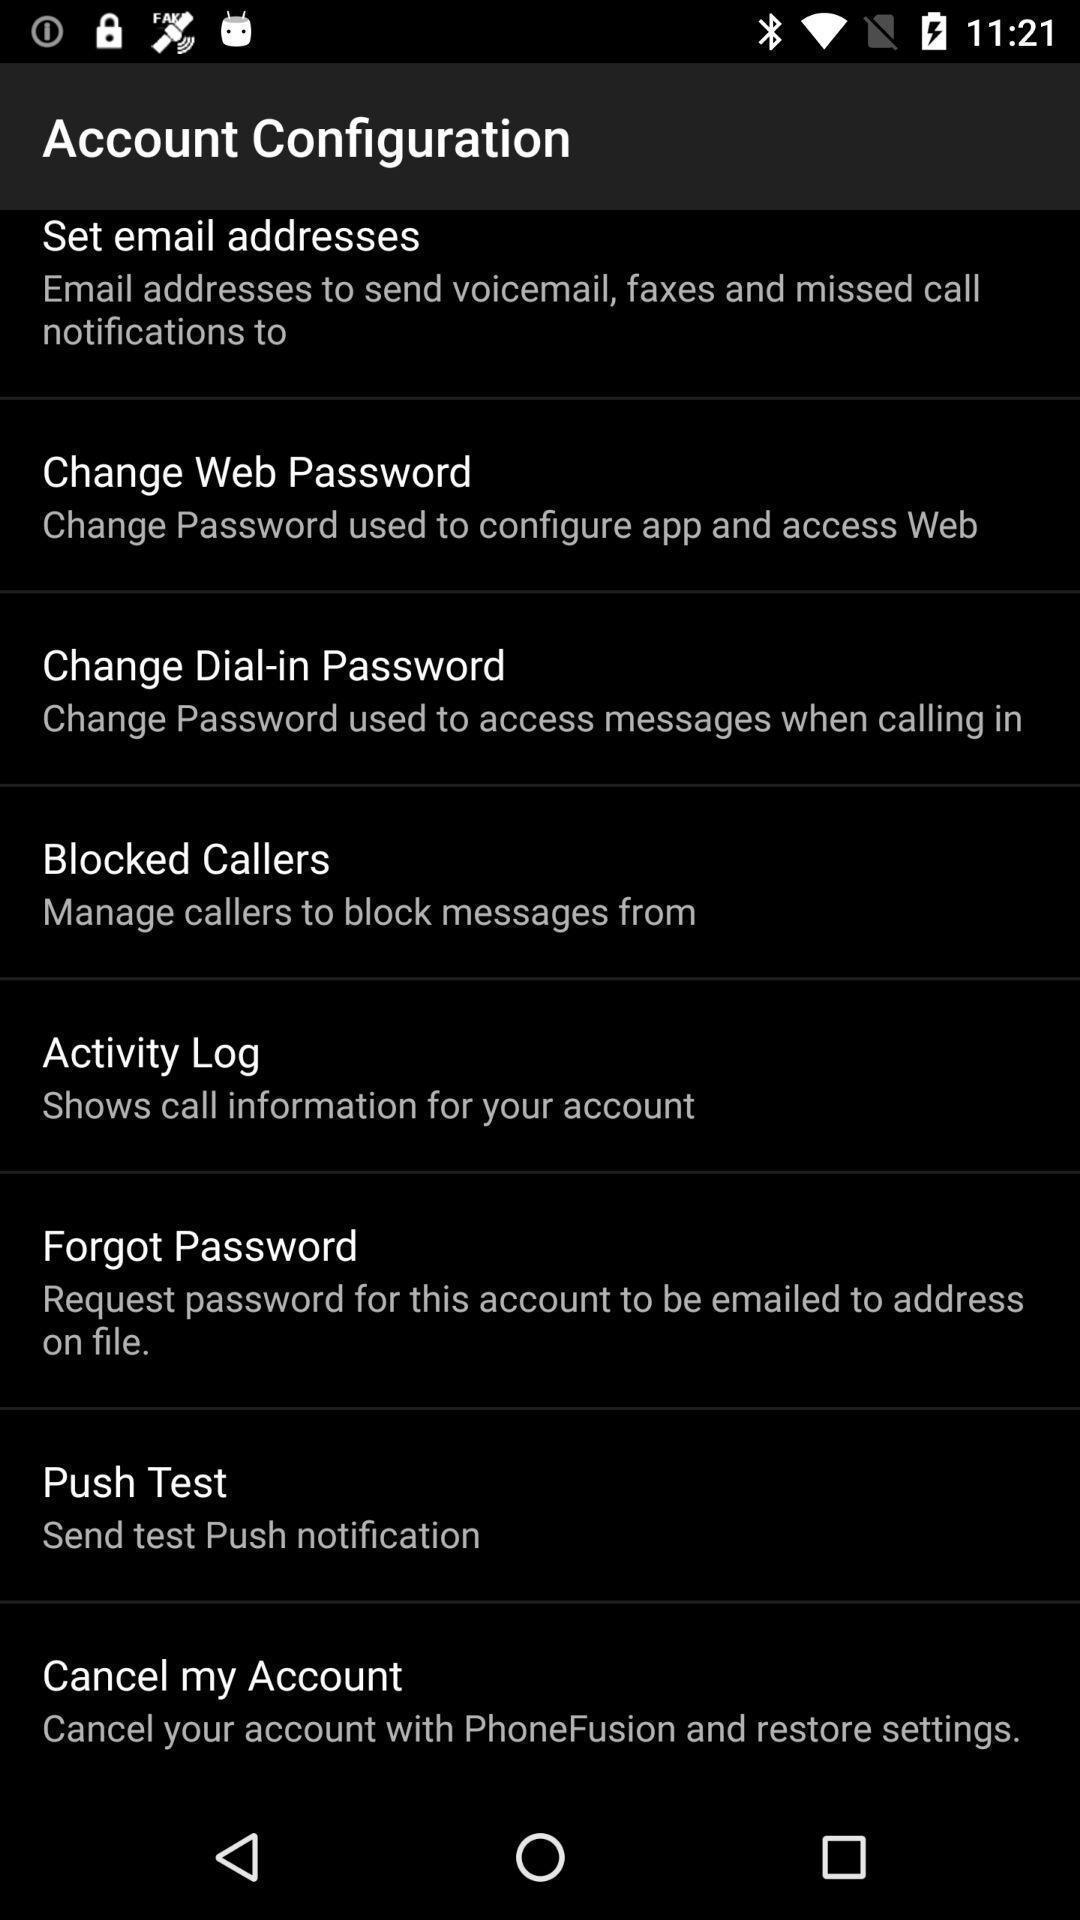What details can you identify in this image? Screen shows an account configuration. 